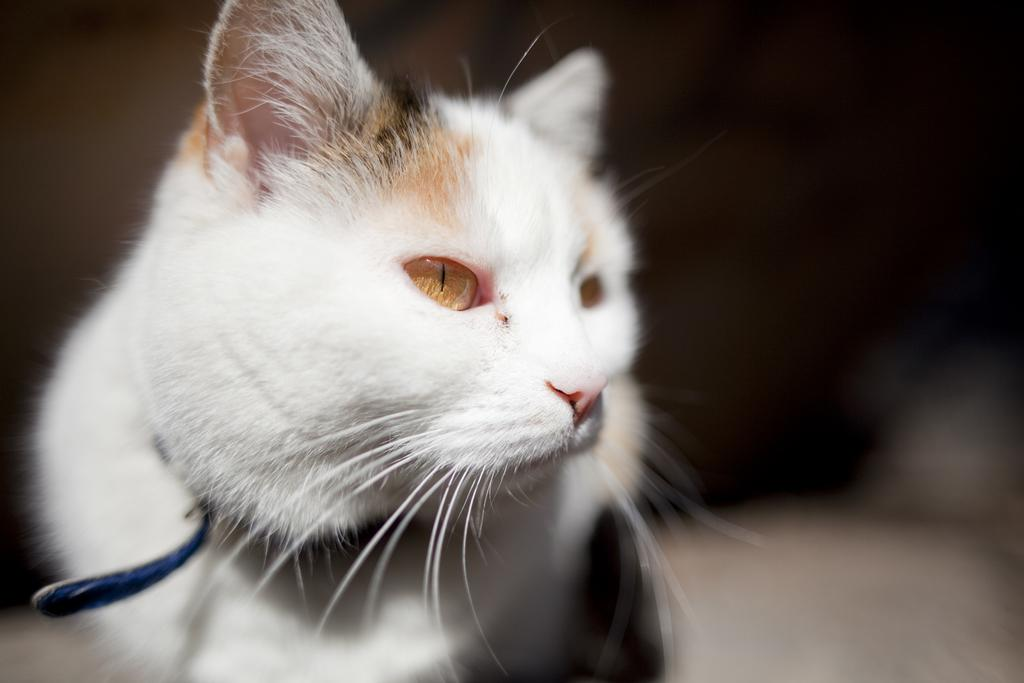What type of animal is in the image? There is a white cat in the image. Can you describe the background of the image? The background of the image is blurred. What type of expansion is happening in the image? There is no expansion happening in the image; it is a static image of a white cat. How many boys are present in the image? There are no boys present in the image; it features a white cat. 